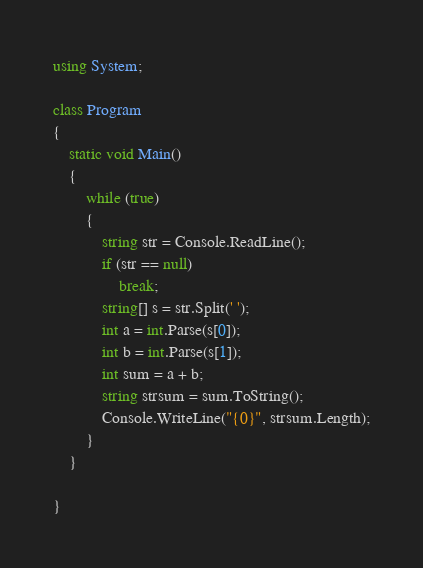Convert code to text. <code><loc_0><loc_0><loc_500><loc_500><_C#_>using System;

class Program
{
    static void Main()
    {
        while (true)
        {
            string str = Console.ReadLine();
            if (str == null)
                break;
            string[] s = str.Split(' ');
            int a = int.Parse(s[0]);
            int b = int.Parse(s[1]);
            int sum = a + b;
            string strsum = sum.ToString();
            Console.WriteLine("{0}", strsum.Length);
        }
    }

}</code> 